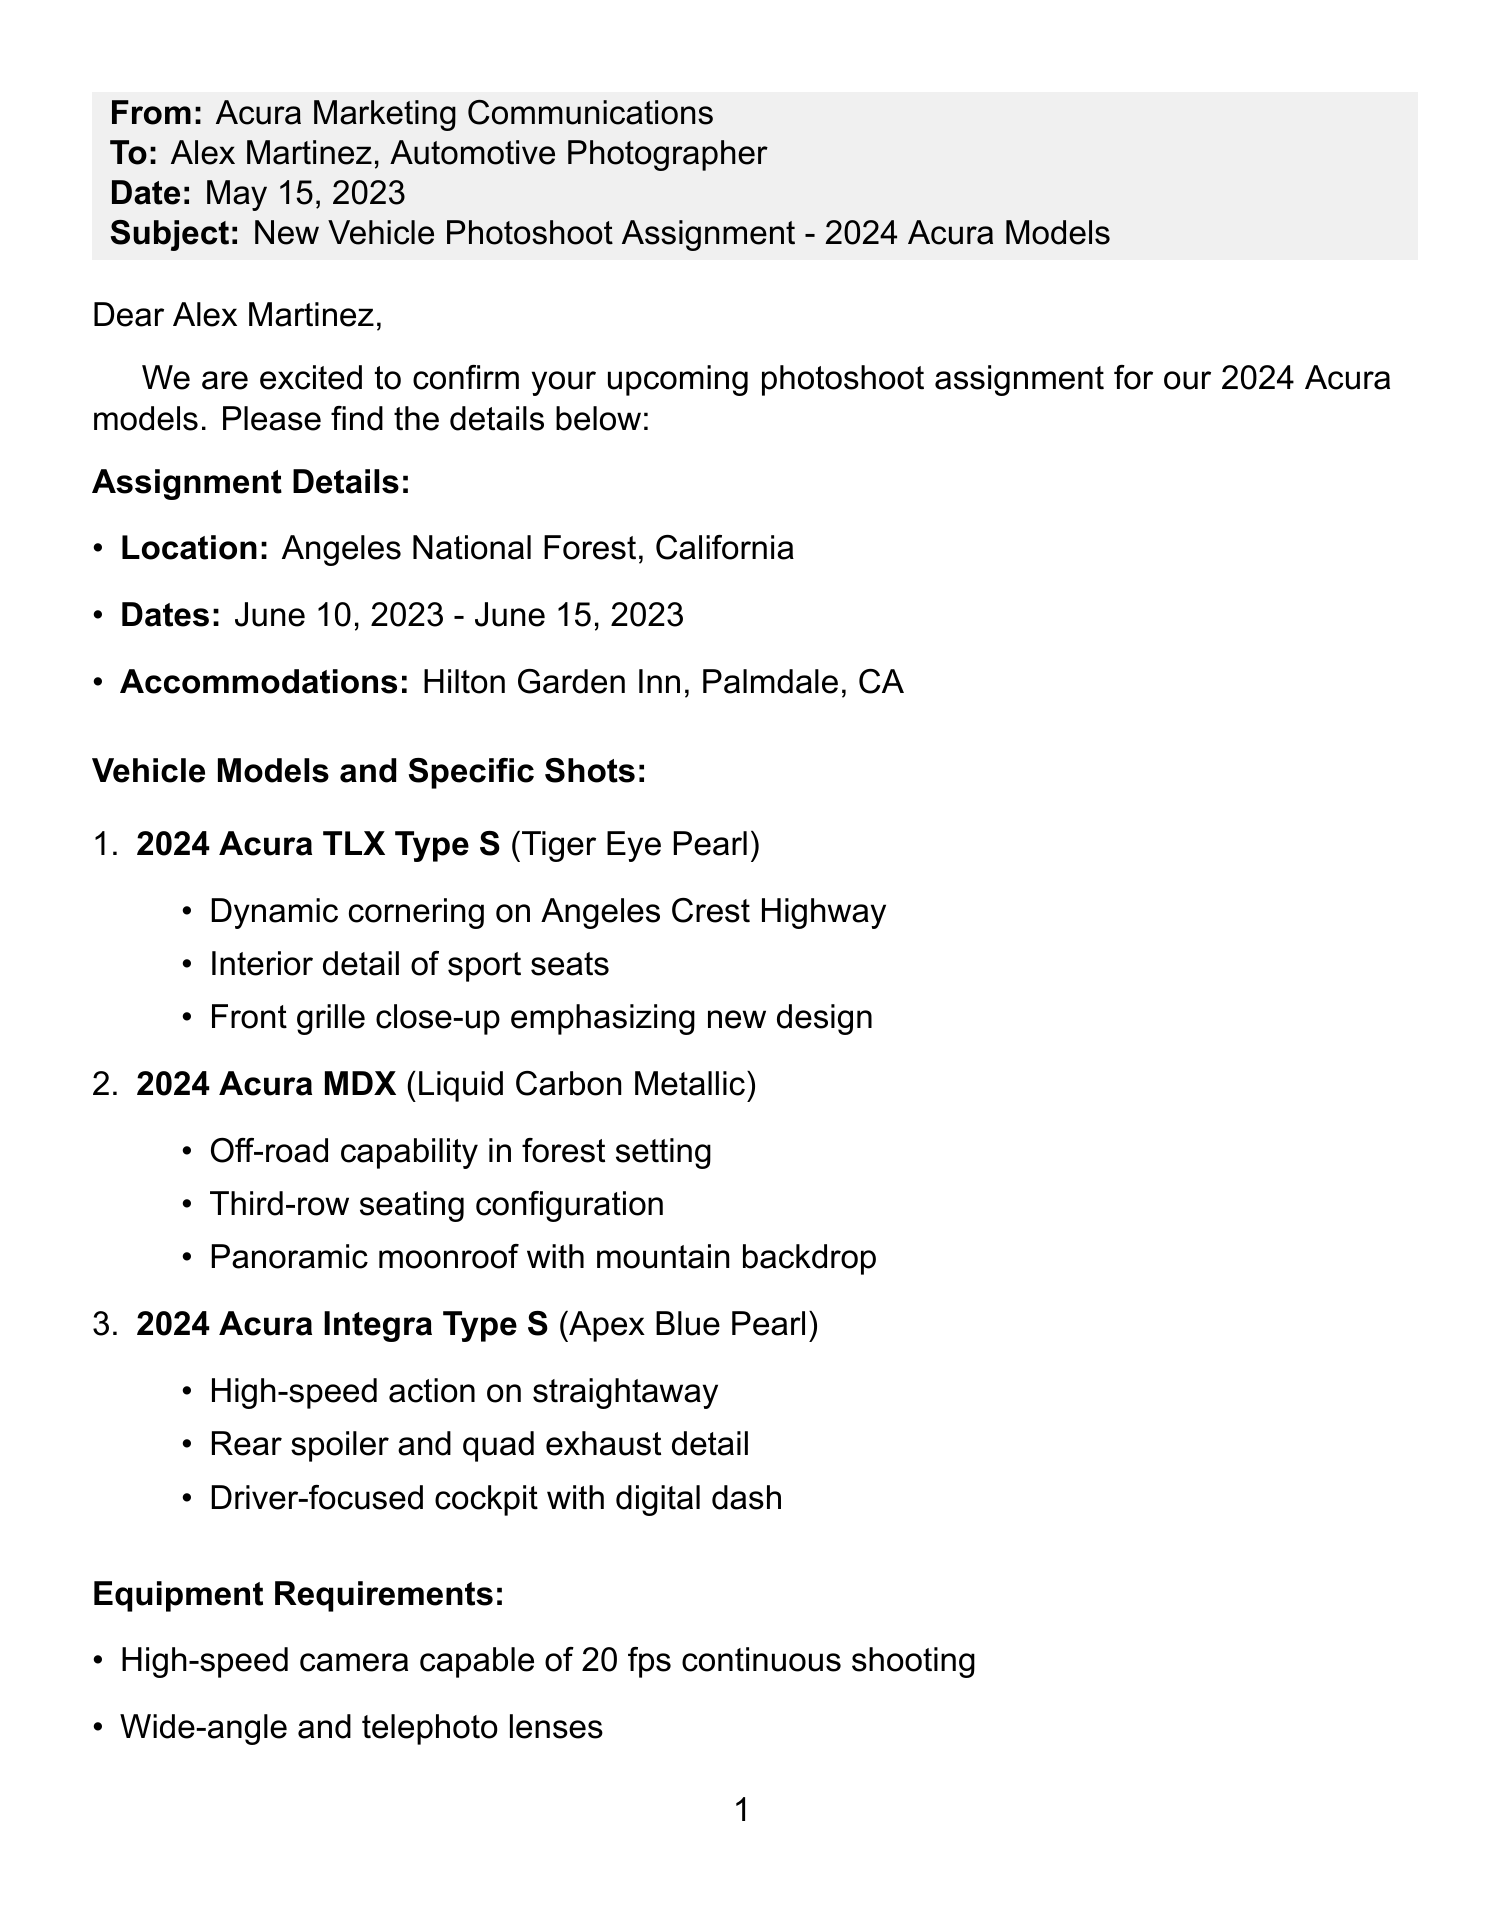What is the location of the photoshoot? The location is specified in the assignment details of the document, indicating where the photoshoot will take place.
Answer: Angeles National Forest, California What are the dates for the photoshoot? The document outlines the start and end dates for the photoshoot assignment, providing specific information about the timing.
Answer: June 10, 2023 - June 15, 2023 What color is the 2024 Acura TLX Type S? The document lists the specific color assigned to each vehicle model, including the 2024 Acura TLX Type S.
Answer: Tiger Eye Pearl How many usable images are required per vehicle? The deliverables section of the document specifies the minimum number of images to be provided for each vehicle model after the photoshoot.
Answer: Minimum 200 usable images per vehicle Who is the Acura Product Specialist on the team? The document contains a list of team members with their roles, including the Acura Product Specialist.
Answer: Sarah Johnson What is the format of the deliverables? The deliverables section of the letter indicates the required file types for the images taken during the photoshoot.
Answer: RAW and JPEG files Which vehicle model requires a shot of the interior detail of sport seats? Each vehicle model in the document has specific shots outlined, making it clear which shots apply to each model.
Answer: 2024 Acura TLX Type S What is the name of the Senior Marketing Manager of Acura? The contact information section of the document includes the name and title of the Senior Marketing Manager for Acura.
Answer: Emily Nakamura What are the special instructions for the photoshoot? The document provides specific guidelines to follow for capturing images, detailing the expectations from the photographer.
Answer: Emphasize Acura's new design language and performance capabilities 